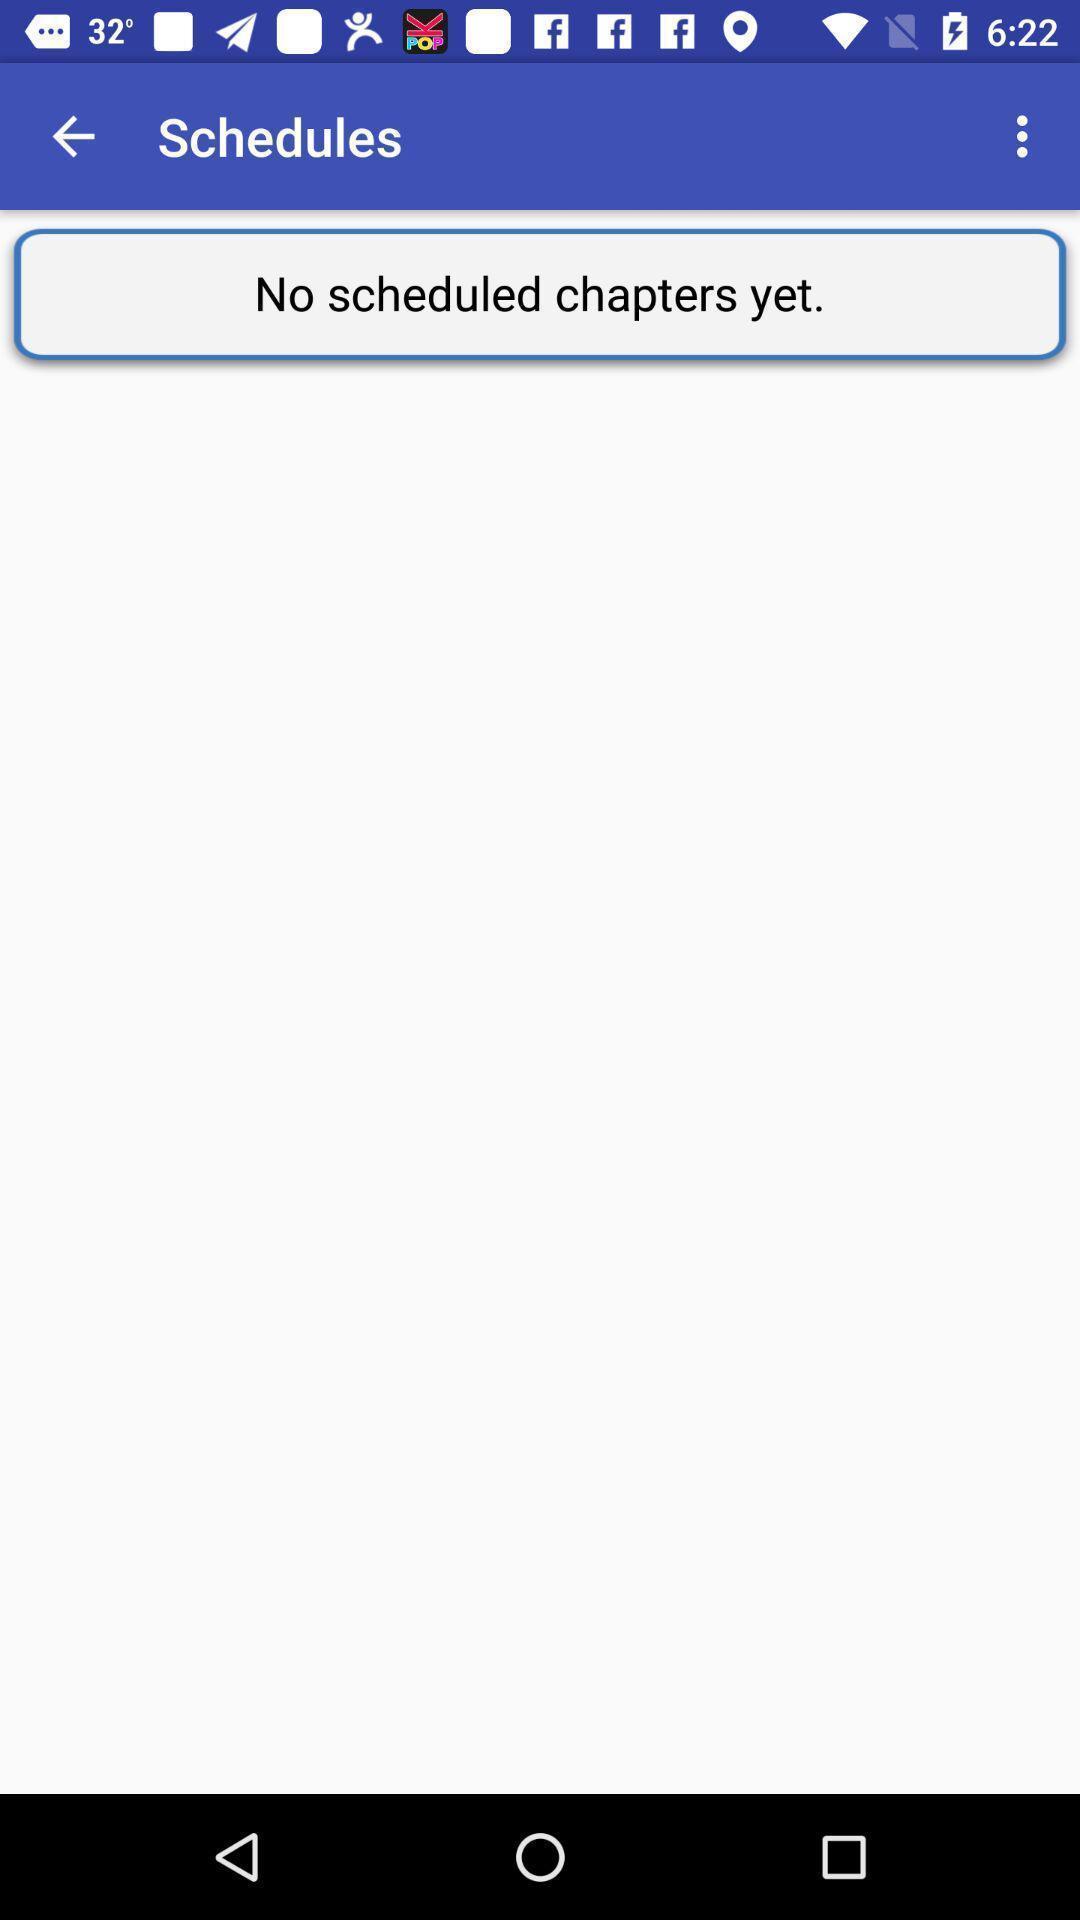What can you discern from this picture? Window displaying the page of schedules chapters. 